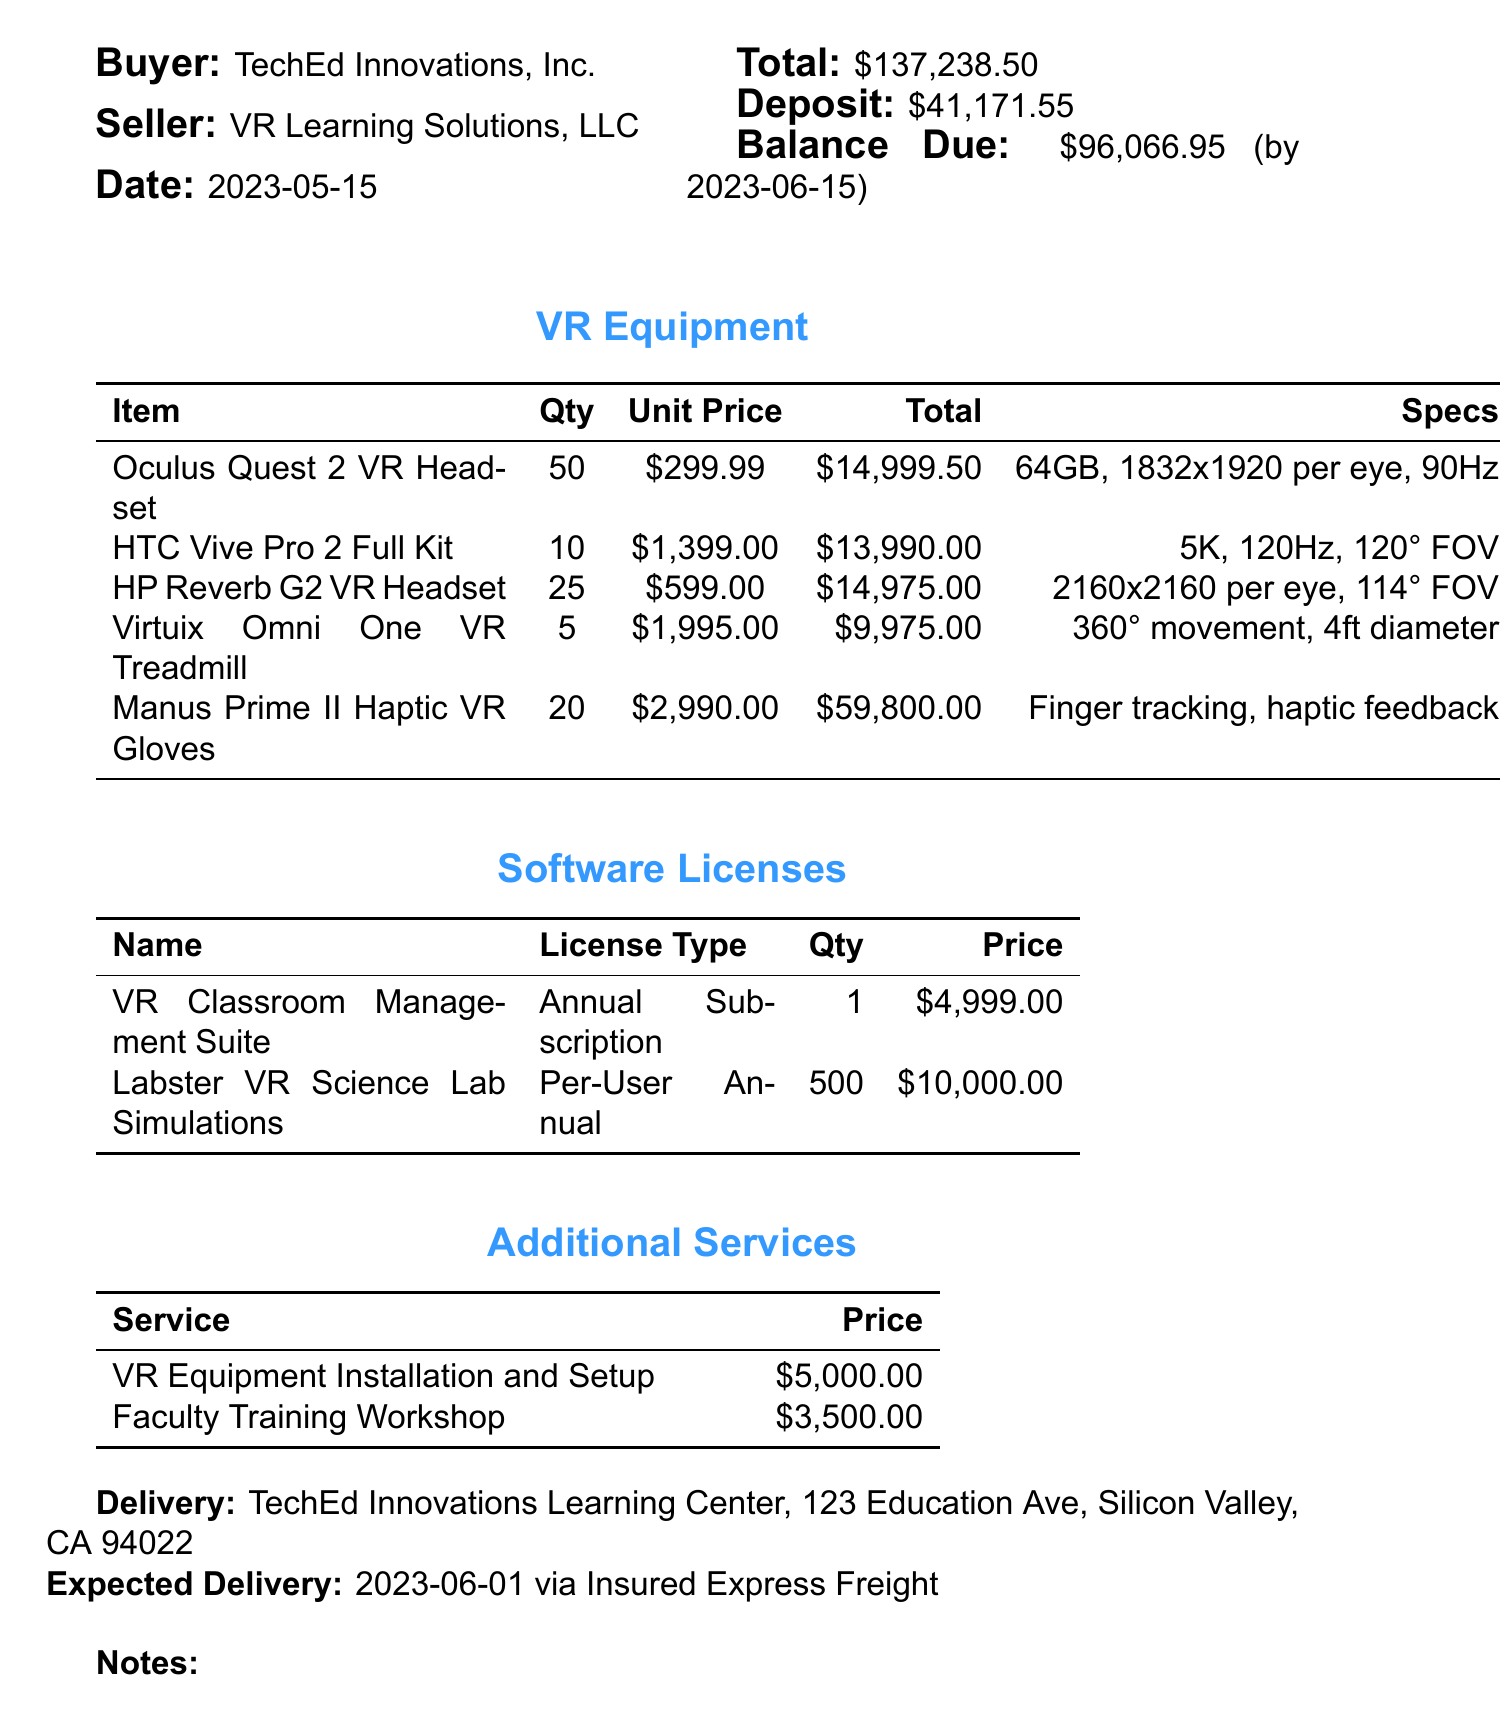What is the purchase order number? The purchase order number is stated in the document and is "PO-EDU-VR-2023-001."
Answer: PO-EDU-VR-2023-001 What is the total amount of the purchase order? The document specifies the total amount as $137,238.50.
Answer: $137,238.50 How many Oculus Quest 2 VR Headsets are being purchased? The document lists the quantity of Oculus Quest 2 VR Headsets as 50.
Answer: 50 What is the expected delivery date? The expected delivery date is clearly mentioned in the delivery information as June 1, 2023.
Answer: June 1, 2023 What is the unit price of the Manus Prime II Haptic VR Gloves? The document provides the unit price for Manus Prime II Haptic VR Gloves, which is $2,990.00.
Answer: $2,990.00 How much will the Faculty Training Workshop cost? The cost for the Faculty Training Workshop is directly stated as $3,500.00.
Answer: $3,500.00 What features are included in the VR Classroom Management Suite? The features of the VR Classroom Management Suite, as listed, include content creation tools, student progress tracking, and collaborative learning environments.
Answer: Content creation tools, student progress tracking, collaborative learning environments What is the total price for Labster VR Science Lab Simulations? The document mentions the total price for Labster VR Science Lab Simulations as $10,000.00 for 500 licenses.
Answer: $10,000.00 What is the payment due date for the balance? The payment due date for the remaining balance is June 15, 2023, according to the payment terms in the document.
Answer: June 15, 2023 